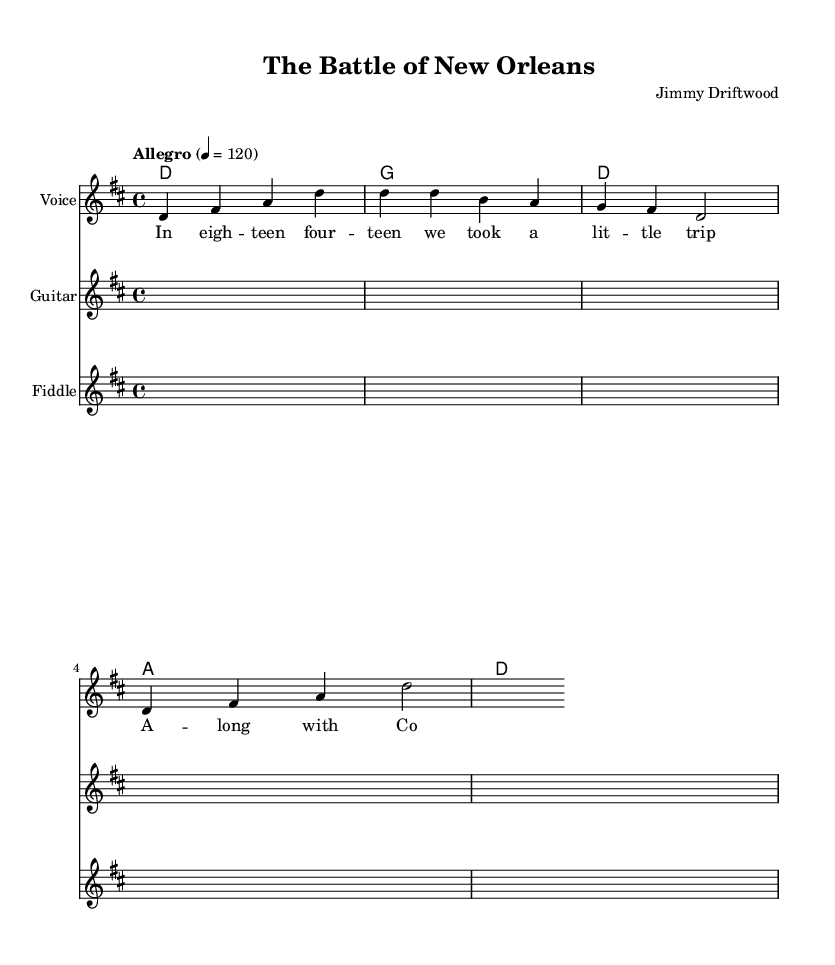What is the title of the song? The title is prominently displayed at the top of the sheet music.
Answer: The Battle of New Orleans What is the key signature of this music? The key signature is indicated at the beginning with sharps or flats; here, it shows two sharps, indicating D major.
Answer: D major What is the time signature of this piece? The time signature is found at the start of the staff and shows the number of beats per measure. Here, it is notated as 4/4, meaning four beats per measure.
Answer: 4/4 What is the tempo marking of the song? The tempo marking is included in the score where it indicates how fast to play the music. Here, it is indicated as "Allegro" at a speed of 120 beats per minute.
Answer: Allegro 4 = 120 What is the first lyric of the song? The lyrics are aligned with the melody in a separate text area beneath the notes. The first word is found at the beginning of the lyric section.
Answer: In How many measures are present in the melody section? By counting the groupings of notes between measure lines in the melody, one can determine the number of measures. The melody segment consists of 4 measures.
Answer: 4 What type of song is "The Battle of New Orleans"? Considering its content and themes, this song qualifies as a classic American folk song that narrates a historical event.
Answer: Folk song 